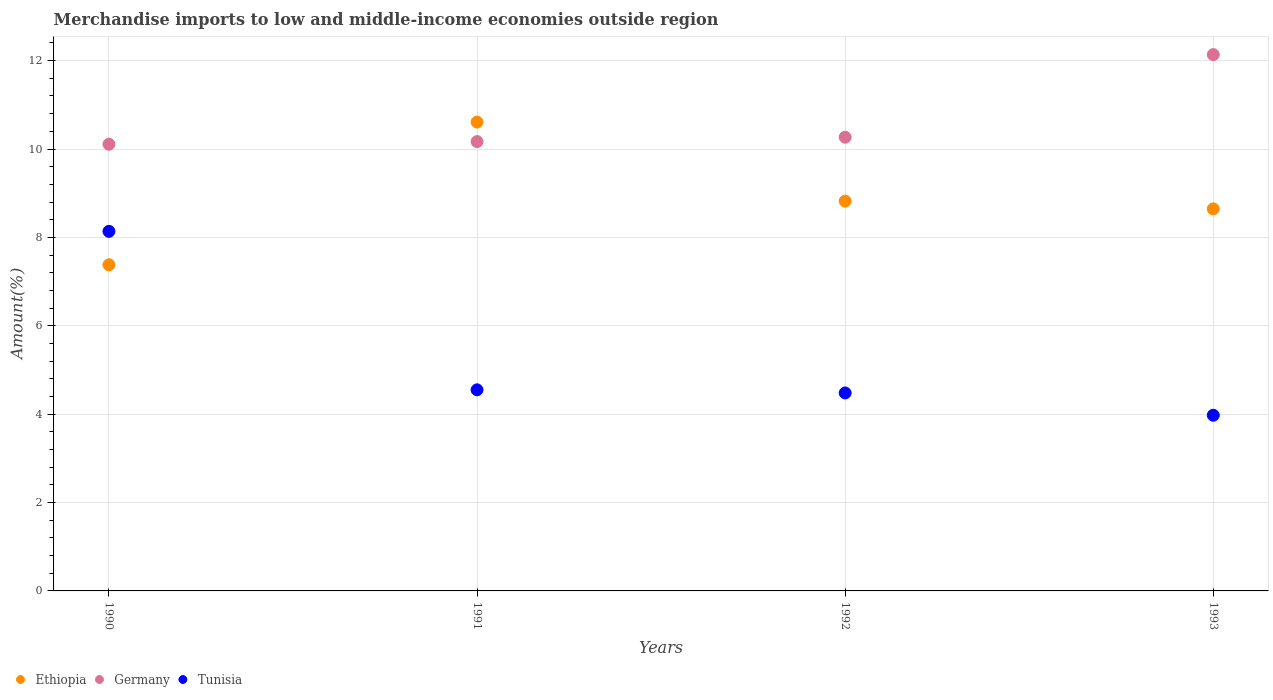How many different coloured dotlines are there?
Keep it short and to the point. 3. What is the percentage of amount earned from merchandise imports in Ethiopia in 1991?
Your answer should be compact. 10.61. Across all years, what is the maximum percentage of amount earned from merchandise imports in Ethiopia?
Ensure brevity in your answer.  10.61. Across all years, what is the minimum percentage of amount earned from merchandise imports in Tunisia?
Give a very brief answer. 3.98. In which year was the percentage of amount earned from merchandise imports in Tunisia minimum?
Your answer should be compact. 1993. What is the total percentage of amount earned from merchandise imports in Ethiopia in the graph?
Provide a succinct answer. 35.46. What is the difference between the percentage of amount earned from merchandise imports in Ethiopia in 1992 and that in 1993?
Give a very brief answer. 0.18. What is the difference between the percentage of amount earned from merchandise imports in Tunisia in 1993 and the percentage of amount earned from merchandise imports in Ethiopia in 1990?
Offer a very short reply. -3.41. What is the average percentage of amount earned from merchandise imports in Tunisia per year?
Provide a short and direct response. 5.29. In the year 1990, what is the difference between the percentage of amount earned from merchandise imports in Germany and percentage of amount earned from merchandise imports in Ethiopia?
Provide a short and direct response. 2.73. In how many years, is the percentage of amount earned from merchandise imports in Tunisia greater than 7.2 %?
Give a very brief answer. 1. What is the ratio of the percentage of amount earned from merchandise imports in Ethiopia in 1990 to that in 1991?
Provide a short and direct response. 0.7. What is the difference between the highest and the second highest percentage of amount earned from merchandise imports in Tunisia?
Your answer should be very brief. 3.59. What is the difference between the highest and the lowest percentage of amount earned from merchandise imports in Germany?
Offer a terse response. 2.03. Is the sum of the percentage of amount earned from merchandise imports in Tunisia in 1992 and 1993 greater than the maximum percentage of amount earned from merchandise imports in Germany across all years?
Provide a succinct answer. No. Is the percentage of amount earned from merchandise imports in Tunisia strictly less than the percentage of amount earned from merchandise imports in Germany over the years?
Provide a short and direct response. Yes. How many years are there in the graph?
Make the answer very short. 4. What is the difference between two consecutive major ticks on the Y-axis?
Give a very brief answer. 2. Are the values on the major ticks of Y-axis written in scientific E-notation?
Offer a very short reply. No. How are the legend labels stacked?
Make the answer very short. Horizontal. What is the title of the graph?
Offer a terse response. Merchandise imports to low and middle-income economies outside region. Does "Fragile and conflict affected situations" appear as one of the legend labels in the graph?
Your answer should be very brief. No. What is the label or title of the X-axis?
Give a very brief answer. Years. What is the label or title of the Y-axis?
Your response must be concise. Amount(%). What is the Amount(%) of Ethiopia in 1990?
Give a very brief answer. 7.38. What is the Amount(%) in Germany in 1990?
Provide a short and direct response. 10.11. What is the Amount(%) in Tunisia in 1990?
Keep it short and to the point. 8.14. What is the Amount(%) in Ethiopia in 1991?
Provide a short and direct response. 10.61. What is the Amount(%) of Germany in 1991?
Provide a short and direct response. 10.17. What is the Amount(%) in Tunisia in 1991?
Offer a terse response. 4.55. What is the Amount(%) in Ethiopia in 1992?
Your response must be concise. 8.82. What is the Amount(%) in Germany in 1992?
Provide a succinct answer. 10.27. What is the Amount(%) of Tunisia in 1992?
Provide a succinct answer. 4.48. What is the Amount(%) in Ethiopia in 1993?
Your answer should be very brief. 8.65. What is the Amount(%) of Germany in 1993?
Make the answer very short. 12.14. What is the Amount(%) in Tunisia in 1993?
Provide a short and direct response. 3.98. Across all years, what is the maximum Amount(%) of Ethiopia?
Keep it short and to the point. 10.61. Across all years, what is the maximum Amount(%) of Germany?
Ensure brevity in your answer.  12.14. Across all years, what is the maximum Amount(%) in Tunisia?
Your response must be concise. 8.14. Across all years, what is the minimum Amount(%) in Ethiopia?
Ensure brevity in your answer.  7.38. Across all years, what is the minimum Amount(%) in Germany?
Make the answer very short. 10.11. Across all years, what is the minimum Amount(%) in Tunisia?
Provide a succinct answer. 3.98. What is the total Amount(%) in Ethiopia in the graph?
Ensure brevity in your answer.  35.46. What is the total Amount(%) in Germany in the graph?
Provide a short and direct response. 42.68. What is the total Amount(%) of Tunisia in the graph?
Ensure brevity in your answer.  21.14. What is the difference between the Amount(%) of Ethiopia in 1990 and that in 1991?
Keep it short and to the point. -3.23. What is the difference between the Amount(%) of Germany in 1990 and that in 1991?
Your response must be concise. -0.06. What is the difference between the Amount(%) in Tunisia in 1990 and that in 1991?
Keep it short and to the point. 3.59. What is the difference between the Amount(%) in Ethiopia in 1990 and that in 1992?
Offer a terse response. -1.44. What is the difference between the Amount(%) in Germany in 1990 and that in 1992?
Your answer should be compact. -0.16. What is the difference between the Amount(%) of Tunisia in 1990 and that in 1992?
Provide a short and direct response. 3.66. What is the difference between the Amount(%) in Ethiopia in 1990 and that in 1993?
Offer a very short reply. -1.27. What is the difference between the Amount(%) of Germany in 1990 and that in 1993?
Your response must be concise. -2.03. What is the difference between the Amount(%) in Tunisia in 1990 and that in 1993?
Make the answer very short. 4.16. What is the difference between the Amount(%) of Ethiopia in 1991 and that in 1992?
Make the answer very short. 1.79. What is the difference between the Amount(%) of Germany in 1991 and that in 1992?
Your answer should be compact. -0.1. What is the difference between the Amount(%) of Tunisia in 1991 and that in 1992?
Your answer should be compact. 0.07. What is the difference between the Amount(%) in Ethiopia in 1991 and that in 1993?
Your answer should be very brief. 1.96. What is the difference between the Amount(%) in Germany in 1991 and that in 1993?
Offer a terse response. -1.97. What is the difference between the Amount(%) in Tunisia in 1991 and that in 1993?
Offer a terse response. 0.58. What is the difference between the Amount(%) in Ethiopia in 1992 and that in 1993?
Make the answer very short. 0.18. What is the difference between the Amount(%) in Germany in 1992 and that in 1993?
Ensure brevity in your answer.  -1.87. What is the difference between the Amount(%) of Tunisia in 1992 and that in 1993?
Ensure brevity in your answer.  0.5. What is the difference between the Amount(%) of Ethiopia in 1990 and the Amount(%) of Germany in 1991?
Your response must be concise. -2.79. What is the difference between the Amount(%) of Ethiopia in 1990 and the Amount(%) of Tunisia in 1991?
Your response must be concise. 2.83. What is the difference between the Amount(%) in Germany in 1990 and the Amount(%) in Tunisia in 1991?
Provide a succinct answer. 5.56. What is the difference between the Amount(%) of Ethiopia in 1990 and the Amount(%) of Germany in 1992?
Your response must be concise. -2.89. What is the difference between the Amount(%) in Ethiopia in 1990 and the Amount(%) in Tunisia in 1992?
Offer a terse response. 2.9. What is the difference between the Amount(%) of Germany in 1990 and the Amount(%) of Tunisia in 1992?
Give a very brief answer. 5.63. What is the difference between the Amount(%) of Ethiopia in 1990 and the Amount(%) of Germany in 1993?
Keep it short and to the point. -4.76. What is the difference between the Amount(%) in Ethiopia in 1990 and the Amount(%) in Tunisia in 1993?
Offer a very short reply. 3.41. What is the difference between the Amount(%) of Germany in 1990 and the Amount(%) of Tunisia in 1993?
Provide a short and direct response. 6.13. What is the difference between the Amount(%) in Ethiopia in 1991 and the Amount(%) in Germany in 1992?
Offer a terse response. 0.34. What is the difference between the Amount(%) of Ethiopia in 1991 and the Amount(%) of Tunisia in 1992?
Make the answer very short. 6.13. What is the difference between the Amount(%) in Germany in 1991 and the Amount(%) in Tunisia in 1992?
Make the answer very short. 5.69. What is the difference between the Amount(%) of Ethiopia in 1991 and the Amount(%) of Germany in 1993?
Keep it short and to the point. -1.53. What is the difference between the Amount(%) in Ethiopia in 1991 and the Amount(%) in Tunisia in 1993?
Ensure brevity in your answer.  6.63. What is the difference between the Amount(%) of Germany in 1991 and the Amount(%) of Tunisia in 1993?
Provide a short and direct response. 6.19. What is the difference between the Amount(%) of Ethiopia in 1992 and the Amount(%) of Germany in 1993?
Your response must be concise. -3.32. What is the difference between the Amount(%) of Ethiopia in 1992 and the Amount(%) of Tunisia in 1993?
Offer a terse response. 4.85. What is the difference between the Amount(%) of Germany in 1992 and the Amount(%) of Tunisia in 1993?
Ensure brevity in your answer.  6.29. What is the average Amount(%) in Ethiopia per year?
Keep it short and to the point. 8.86. What is the average Amount(%) of Germany per year?
Your answer should be compact. 10.67. What is the average Amount(%) in Tunisia per year?
Your answer should be very brief. 5.29. In the year 1990, what is the difference between the Amount(%) of Ethiopia and Amount(%) of Germany?
Keep it short and to the point. -2.73. In the year 1990, what is the difference between the Amount(%) of Ethiopia and Amount(%) of Tunisia?
Offer a very short reply. -0.76. In the year 1990, what is the difference between the Amount(%) of Germany and Amount(%) of Tunisia?
Your answer should be compact. 1.97. In the year 1991, what is the difference between the Amount(%) in Ethiopia and Amount(%) in Germany?
Give a very brief answer. 0.44. In the year 1991, what is the difference between the Amount(%) of Ethiopia and Amount(%) of Tunisia?
Your response must be concise. 6.06. In the year 1991, what is the difference between the Amount(%) in Germany and Amount(%) in Tunisia?
Provide a succinct answer. 5.62. In the year 1992, what is the difference between the Amount(%) in Ethiopia and Amount(%) in Germany?
Offer a very short reply. -1.45. In the year 1992, what is the difference between the Amount(%) of Ethiopia and Amount(%) of Tunisia?
Give a very brief answer. 4.34. In the year 1992, what is the difference between the Amount(%) of Germany and Amount(%) of Tunisia?
Ensure brevity in your answer.  5.79. In the year 1993, what is the difference between the Amount(%) in Ethiopia and Amount(%) in Germany?
Your answer should be compact. -3.49. In the year 1993, what is the difference between the Amount(%) of Ethiopia and Amount(%) of Tunisia?
Your answer should be very brief. 4.67. In the year 1993, what is the difference between the Amount(%) in Germany and Amount(%) in Tunisia?
Your answer should be compact. 8.16. What is the ratio of the Amount(%) in Ethiopia in 1990 to that in 1991?
Make the answer very short. 0.7. What is the ratio of the Amount(%) in Tunisia in 1990 to that in 1991?
Give a very brief answer. 1.79. What is the ratio of the Amount(%) of Ethiopia in 1990 to that in 1992?
Give a very brief answer. 0.84. What is the ratio of the Amount(%) of Germany in 1990 to that in 1992?
Keep it short and to the point. 0.98. What is the ratio of the Amount(%) in Tunisia in 1990 to that in 1992?
Ensure brevity in your answer.  1.82. What is the ratio of the Amount(%) in Ethiopia in 1990 to that in 1993?
Make the answer very short. 0.85. What is the ratio of the Amount(%) of Germany in 1990 to that in 1993?
Give a very brief answer. 0.83. What is the ratio of the Amount(%) in Tunisia in 1990 to that in 1993?
Give a very brief answer. 2.05. What is the ratio of the Amount(%) in Ethiopia in 1991 to that in 1992?
Provide a short and direct response. 1.2. What is the ratio of the Amount(%) of Tunisia in 1991 to that in 1992?
Offer a terse response. 1.02. What is the ratio of the Amount(%) in Ethiopia in 1991 to that in 1993?
Provide a succinct answer. 1.23. What is the ratio of the Amount(%) in Germany in 1991 to that in 1993?
Your answer should be very brief. 0.84. What is the ratio of the Amount(%) in Tunisia in 1991 to that in 1993?
Provide a short and direct response. 1.14. What is the ratio of the Amount(%) in Ethiopia in 1992 to that in 1993?
Give a very brief answer. 1.02. What is the ratio of the Amount(%) of Germany in 1992 to that in 1993?
Your answer should be compact. 0.85. What is the ratio of the Amount(%) in Tunisia in 1992 to that in 1993?
Your response must be concise. 1.13. What is the difference between the highest and the second highest Amount(%) of Ethiopia?
Give a very brief answer. 1.79. What is the difference between the highest and the second highest Amount(%) in Germany?
Ensure brevity in your answer.  1.87. What is the difference between the highest and the second highest Amount(%) in Tunisia?
Make the answer very short. 3.59. What is the difference between the highest and the lowest Amount(%) in Ethiopia?
Your response must be concise. 3.23. What is the difference between the highest and the lowest Amount(%) of Germany?
Your answer should be very brief. 2.03. What is the difference between the highest and the lowest Amount(%) in Tunisia?
Make the answer very short. 4.16. 